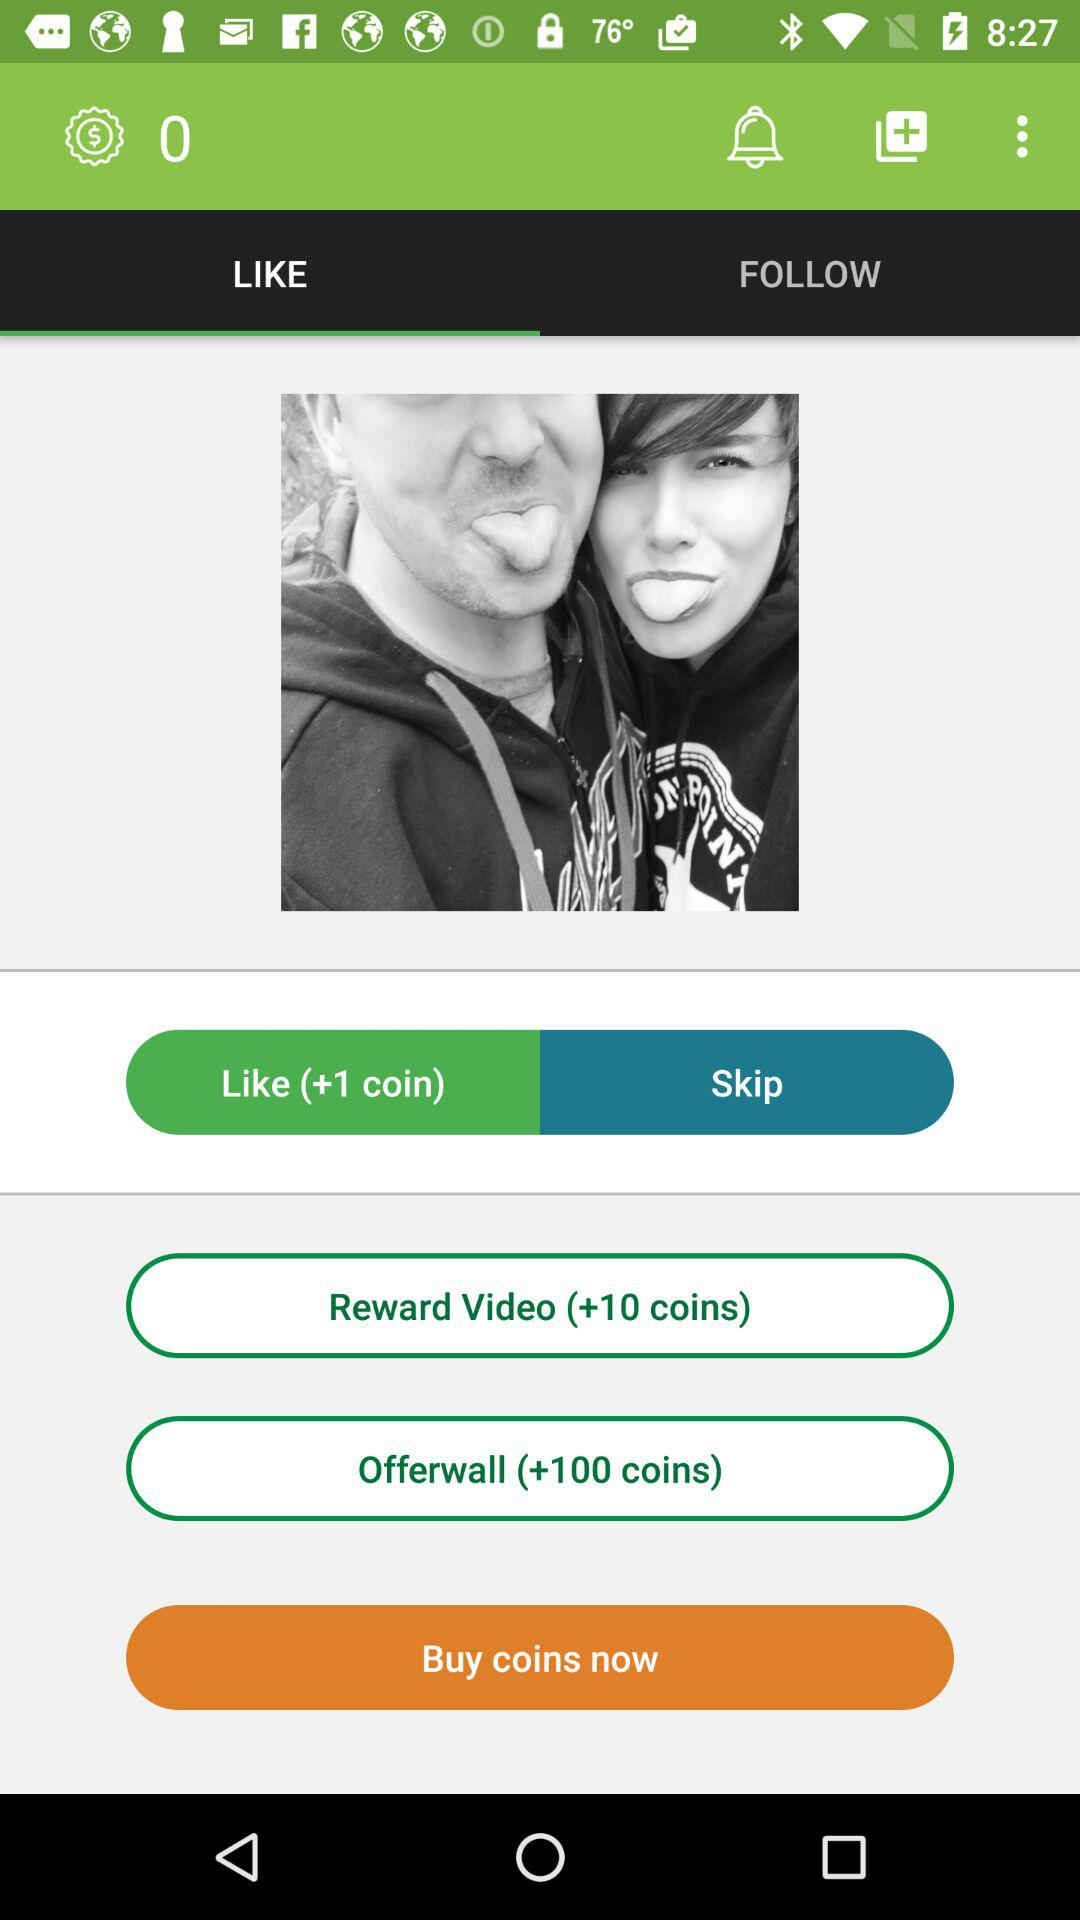Which tab is selected? The selected tab is "LIKE". 